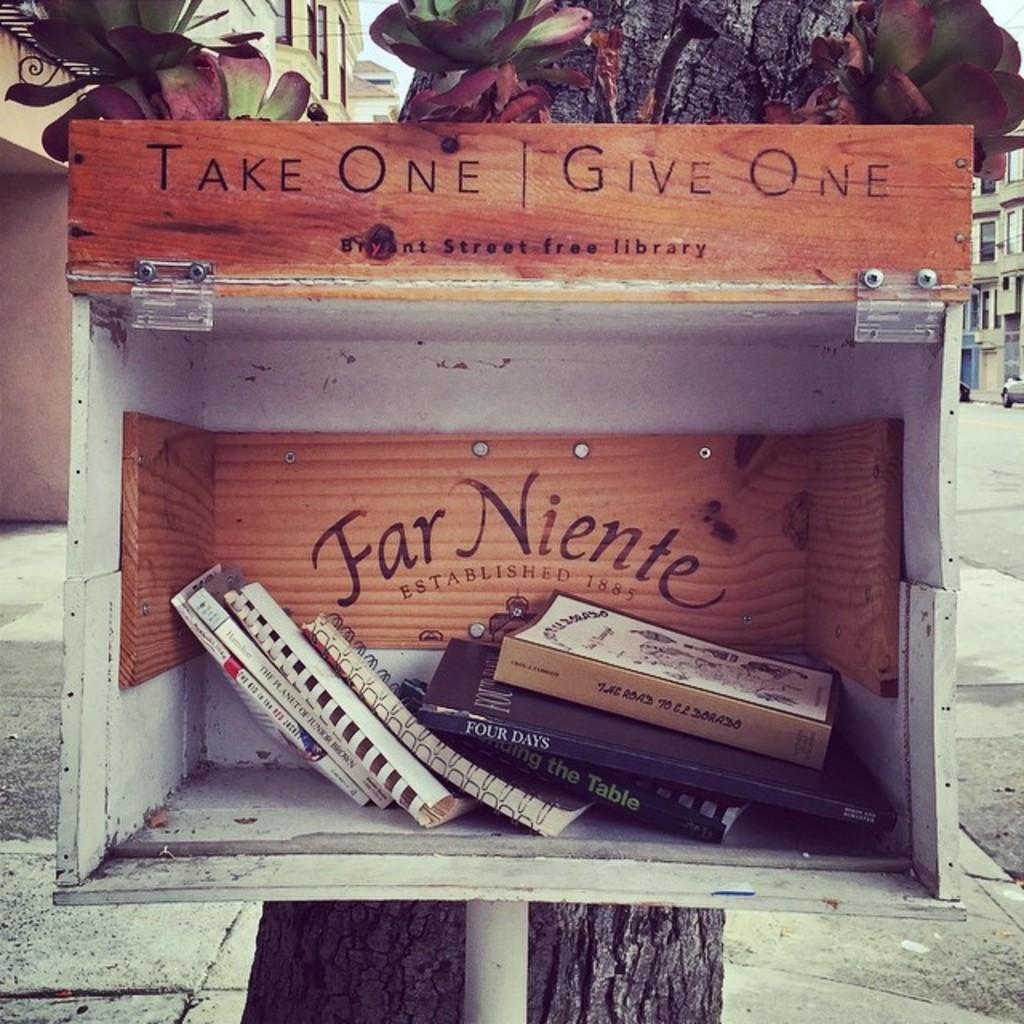<image>
Offer a succinct explanation of the picture presented. A box that says Take One Give One contains a number of books. 